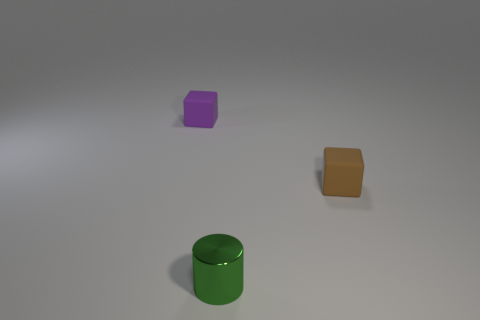Is there any other thing that has the same material as the purple thing?
Offer a terse response. Yes. What is the shape of the rubber object that is in front of the matte thing that is behind the cube in front of the purple thing?
Your response must be concise. Cube. How many other things are there of the same shape as the tiny purple thing?
Provide a succinct answer. 1. There is a metal cylinder that is the same size as the brown thing; what color is it?
Offer a very short reply. Green. What number of balls are either tiny green shiny things or small purple rubber things?
Your answer should be compact. 0. What number of big green spheres are there?
Your response must be concise. 0. Is the shape of the small purple matte object the same as the tiny green metallic thing in front of the brown rubber object?
Give a very brief answer. No. How many objects are either brown matte blocks or yellow matte blocks?
Your answer should be compact. 1. The matte thing that is in front of the cube that is left of the brown thing is what shape?
Your answer should be compact. Cube. Is the shape of the rubber object that is to the left of the tiny cylinder the same as  the metal thing?
Provide a succinct answer. No. 